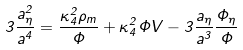Convert formula to latex. <formula><loc_0><loc_0><loc_500><loc_500>3 \frac { a _ { \eta } ^ { 2 } } { a ^ { 4 } } = \frac { \kappa _ { 4 } ^ { 2 } \rho _ { m } } { \Phi } + \kappa _ { 4 } ^ { 2 } \Phi V - 3 \frac { a _ { \eta } } { a ^ { 3 } } \frac { \Phi _ { \eta } } { \Phi }</formula> 